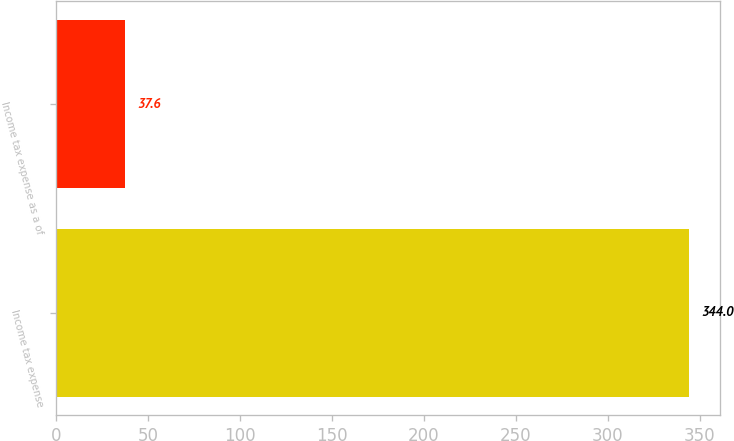<chart> <loc_0><loc_0><loc_500><loc_500><bar_chart><fcel>Income tax expense<fcel>Income tax expense as a of<nl><fcel>344<fcel>37.6<nl></chart> 